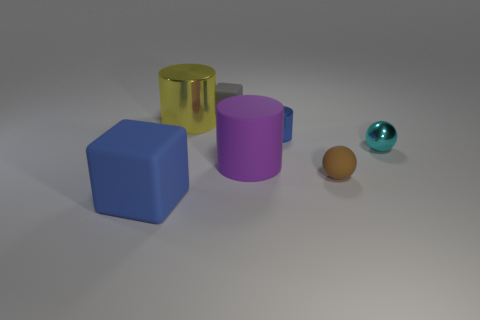There is a shiny cylinder left of the large object that is to the right of the small matte thing behind the tiny brown thing; what is its size?
Ensure brevity in your answer.  Large. How many small blue things are the same material as the cyan thing?
Give a very brief answer. 1. What is the color of the rubber block that is in front of the matte thing behind the big yellow cylinder?
Your answer should be compact. Blue. What number of objects are either small balls or matte objects that are right of the blue cylinder?
Provide a succinct answer. 2. Is there a shiny cylinder that has the same color as the big matte cube?
Give a very brief answer. Yes. How many cyan objects are either big blocks or shiny balls?
Make the answer very short. 1. How many other objects are the same size as the purple cylinder?
Your response must be concise. 2. How many large things are either cyan objects or purple balls?
Keep it short and to the point. 0. Do the yellow metal object and the blue thing behind the rubber cylinder have the same size?
Keep it short and to the point. No. How many other objects are the same shape as the big yellow object?
Provide a succinct answer. 2. 